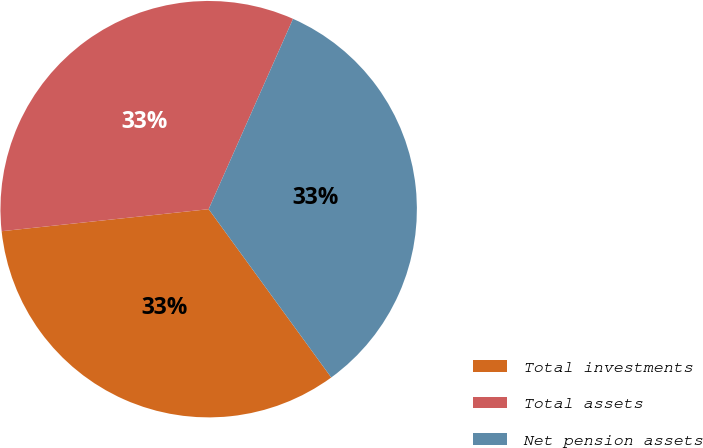Convert chart to OTSL. <chart><loc_0><loc_0><loc_500><loc_500><pie_chart><fcel>Total investments<fcel>Total assets<fcel>Net pension assets<nl><fcel>33.33%<fcel>33.33%<fcel>33.34%<nl></chart> 